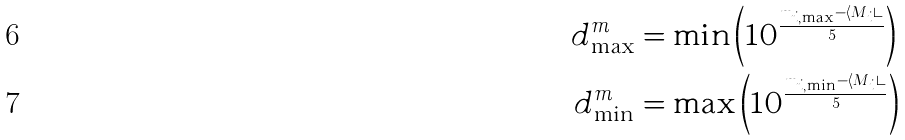<formula> <loc_0><loc_0><loc_500><loc_500>d _ { \max } ^ { m } & = \min \left ( 1 0 ^ { \frac { m _ { i , \max } - \langle M _ { i } \rangle } { 5 } } \right ) \\ d _ { \min } ^ { m } & = \max \left ( 1 0 ^ { \frac { m _ { i , \min } - \langle M _ { i } \rangle } { 5 } } \right )</formula> 